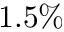Convert formula to latex. <formula><loc_0><loc_0><loc_500><loc_500>1 . 5 \%</formula> 